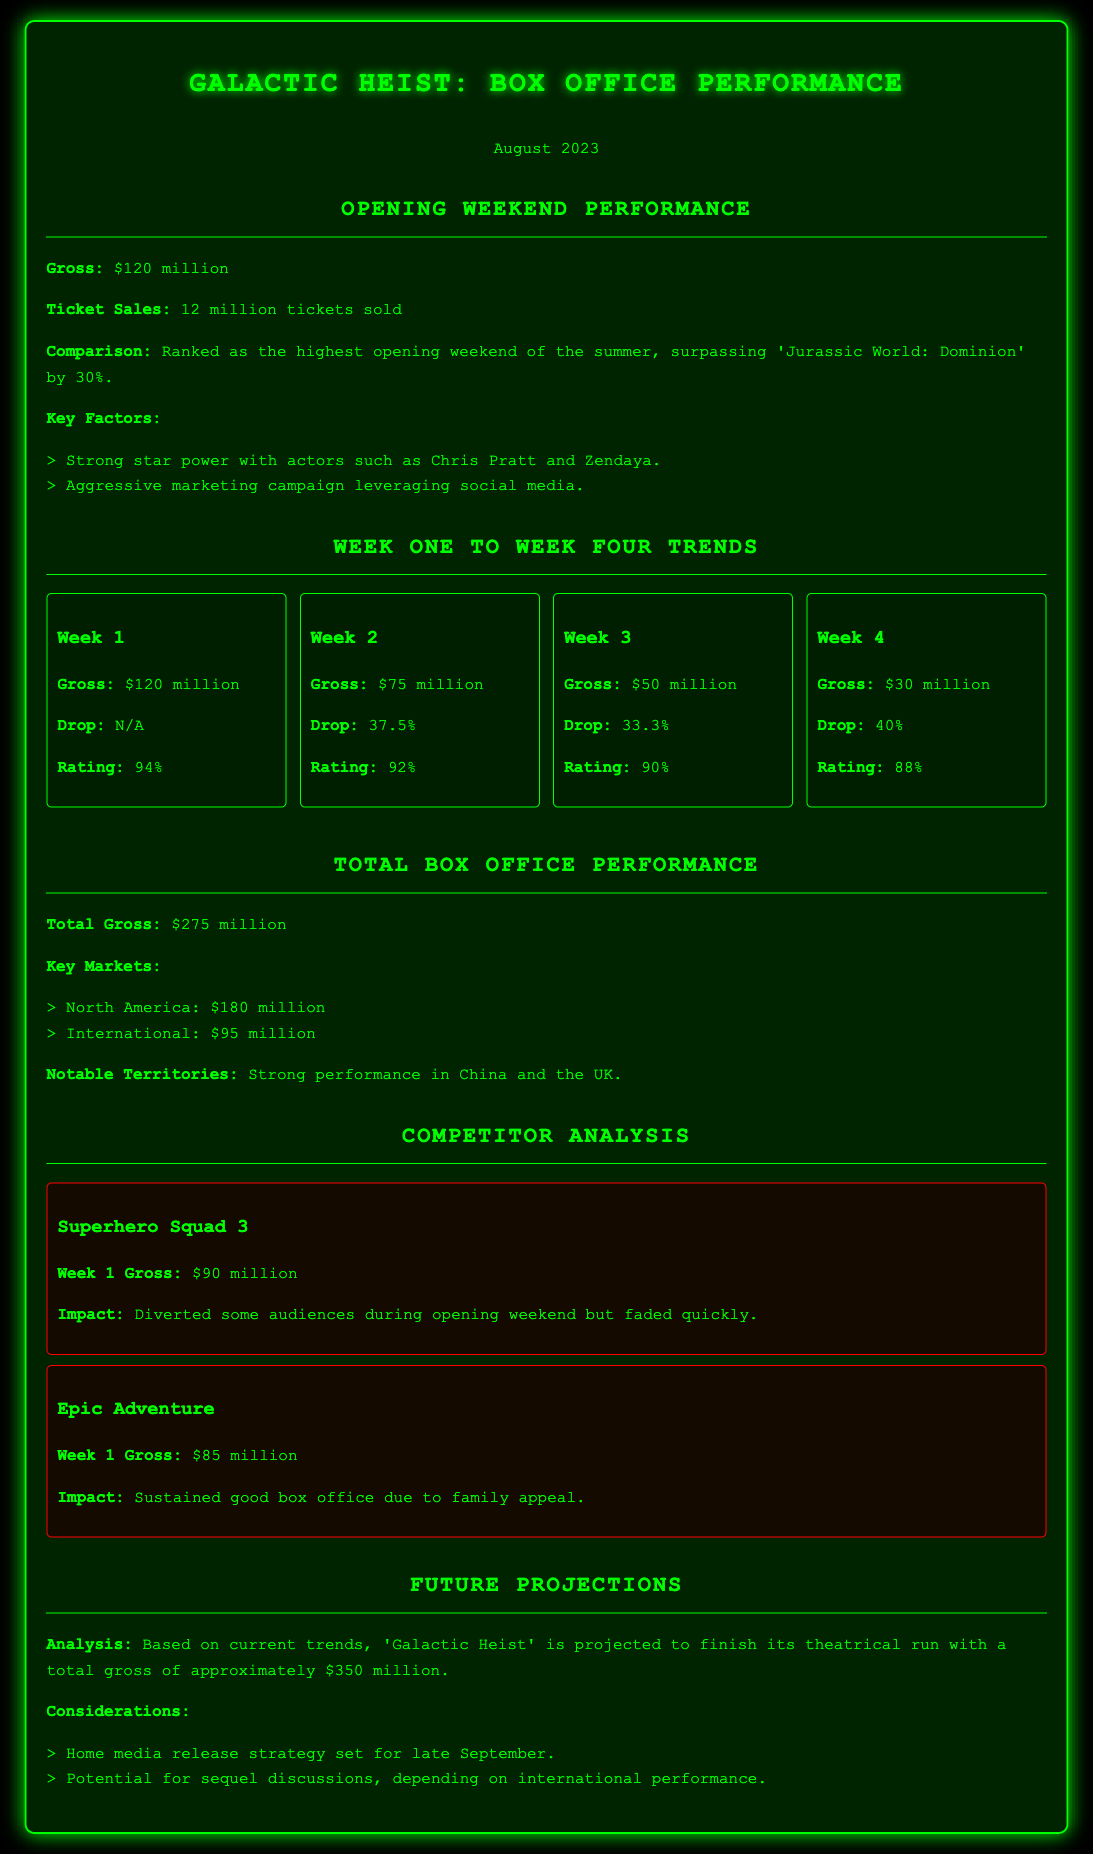What was the gross for the opening weekend? The gross for the opening weekend is specifically stated in the document as $120 million.
Answer: $120 million What was the ticket sales for the opening weekend? The document mentions that 12 million tickets were sold during the opening weekend.
Answer: 12 million tickets What was the total gross for the month? The total gross is provided in the document as $275 million, representing the earnings throughout the month.
Answer: $275 million Which week showed the highest drop in gross revenue? By analyzing the drops for each week, Week 4 has the highest drop at 40%.
Answer: 40% What is the average rating across the first four weeks? The ratings for the four weeks are 94%, 92%, 90%, and 88%. The average can be calculated as (94 + 92 + 90 + 88) / 4 = 91%.
Answer: 91% What is the projected total gross for 'Galactic Heist'? The document states that the projection for the total gross is approximately $350 million.
Answer: $350 million Which competitor had the highest Week 1 gross? The competitors listed show that 'Superhero Squad 3' grossed $90 million in Week 1, making it the highest among competitors.
Answer: Superhero Squad 3 What are the two notable territories mentioned for strong performance? The document specifies that there was strong performance in China and the UK.
Answer: China and the UK What is the home media release strategy set for? The home media release strategy is mentioned to be set for late September in the document.
Answer: Late September 